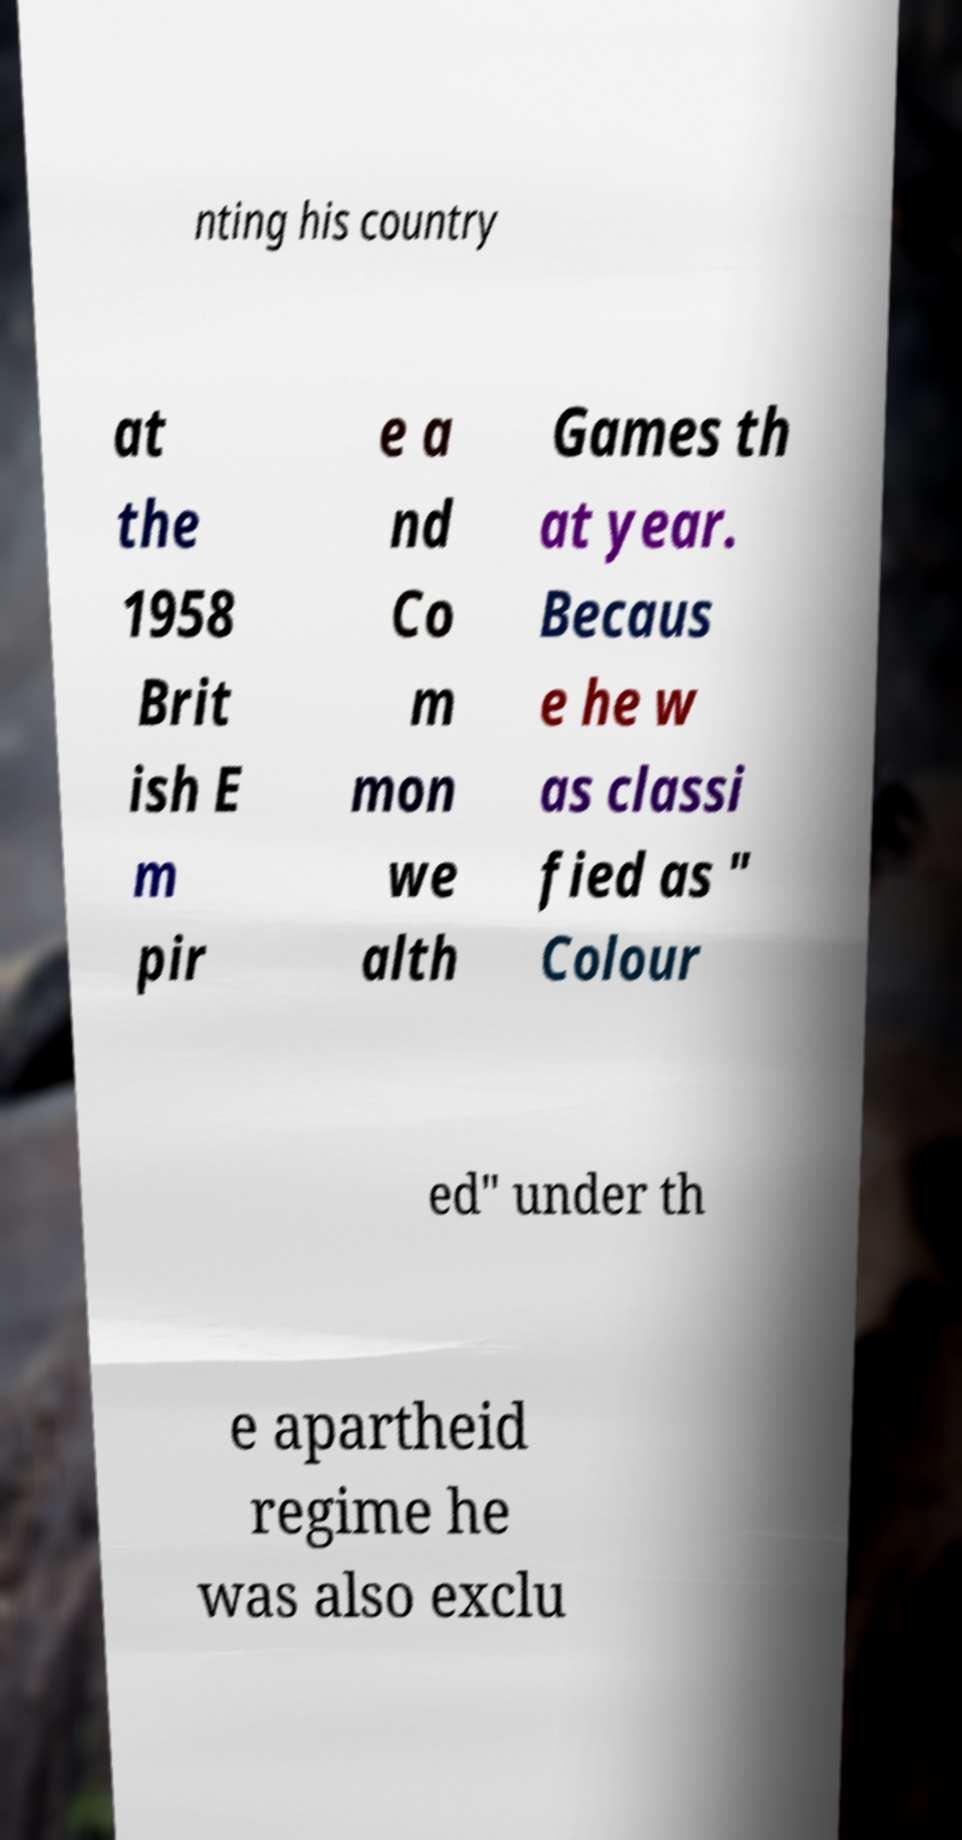Could you assist in decoding the text presented in this image and type it out clearly? nting his country at the 1958 Brit ish E m pir e a nd Co m mon we alth Games th at year. Becaus e he w as classi fied as " Colour ed" under th e apartheid regime he was also exclu 